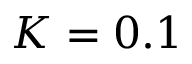Convert formula to latex. <formula><loc_0><loc_0><loc_500><loc_500>K = 0 . 1</formula> 